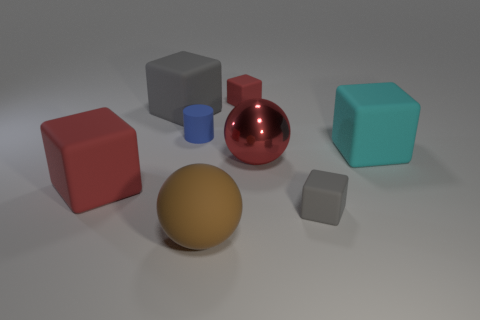Subtract all large gray cubes. How many cubes are left? 4 Add 1 cyan things. How many objects exist? 9 Subtract all cylinders. How many objects are left? 7 Subtract all green balls. How many purple cylinders are left? 0 Subtract all small blue matte objects. Subtract all cyan rubber blocks. How many objects are left? 6 Add 1 blue things. How many blue things are left? 2 Add 3 tiny gray rubber objects. How many tiny gray rubber objects exist? 4 Subtract all red cubes. How many cubes are left? 3 Subtract 1 cyan blocks. How many objects are left? 7 Subtract 1 cylinders. How many cylinders are left? 0 